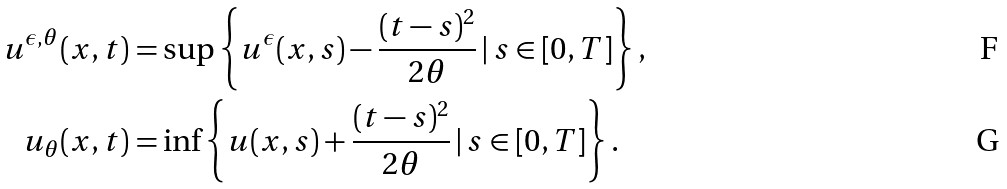<formula> <loc_0><loc_0><loc_500><loc_500>u ^ { \epsilon , \theta } ( x , t ) & = \sup \left \{ u ^ { \epsilon } ( x , s ) - \frac { ( t - s ) ^ { 2 } } { 2 \theta } \, | \, s \in [ 0 , T ] \right \} , \\ \quad u _ { \theta } ( x , t ) & = \inf \left \{ u ( x , s ) + \frac { ( t - s ) ^ { 2 } } { 2 \theta } \, | \, s \in [ 0 , T ] \right \} .</formula> 